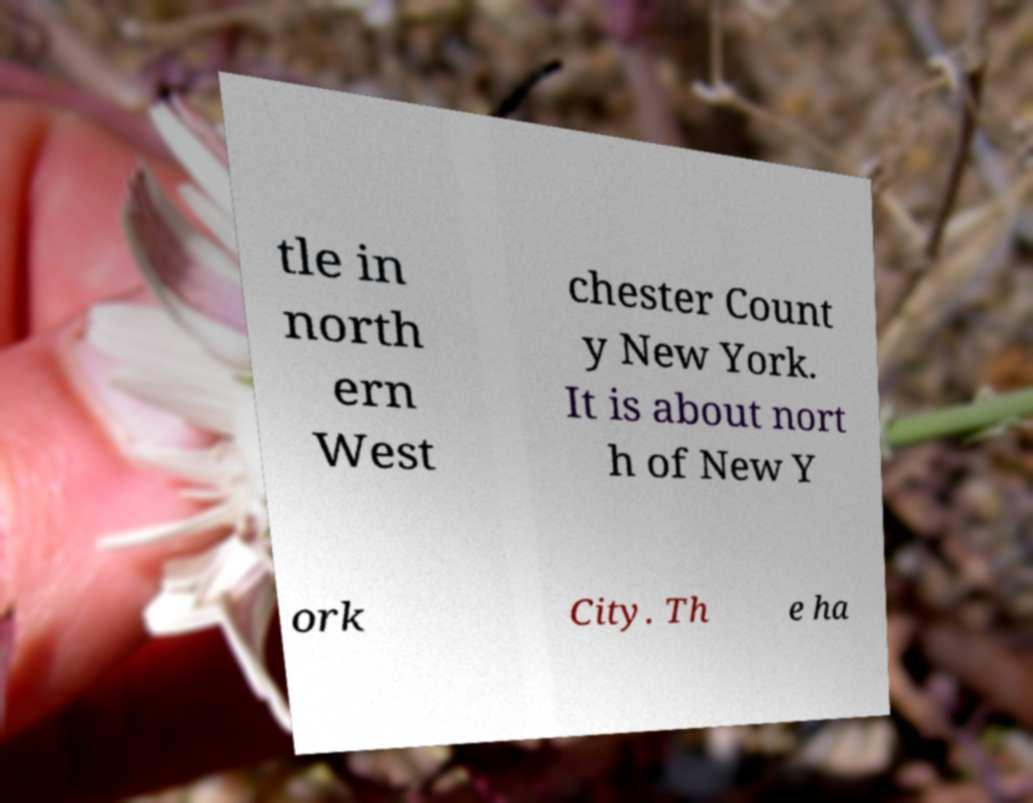For documentation purposes, I need the text within this image transcribed. Could you provide that? tle in north ern West chester Count y New York. It is about nort h of New Y ork City. Th e ha 